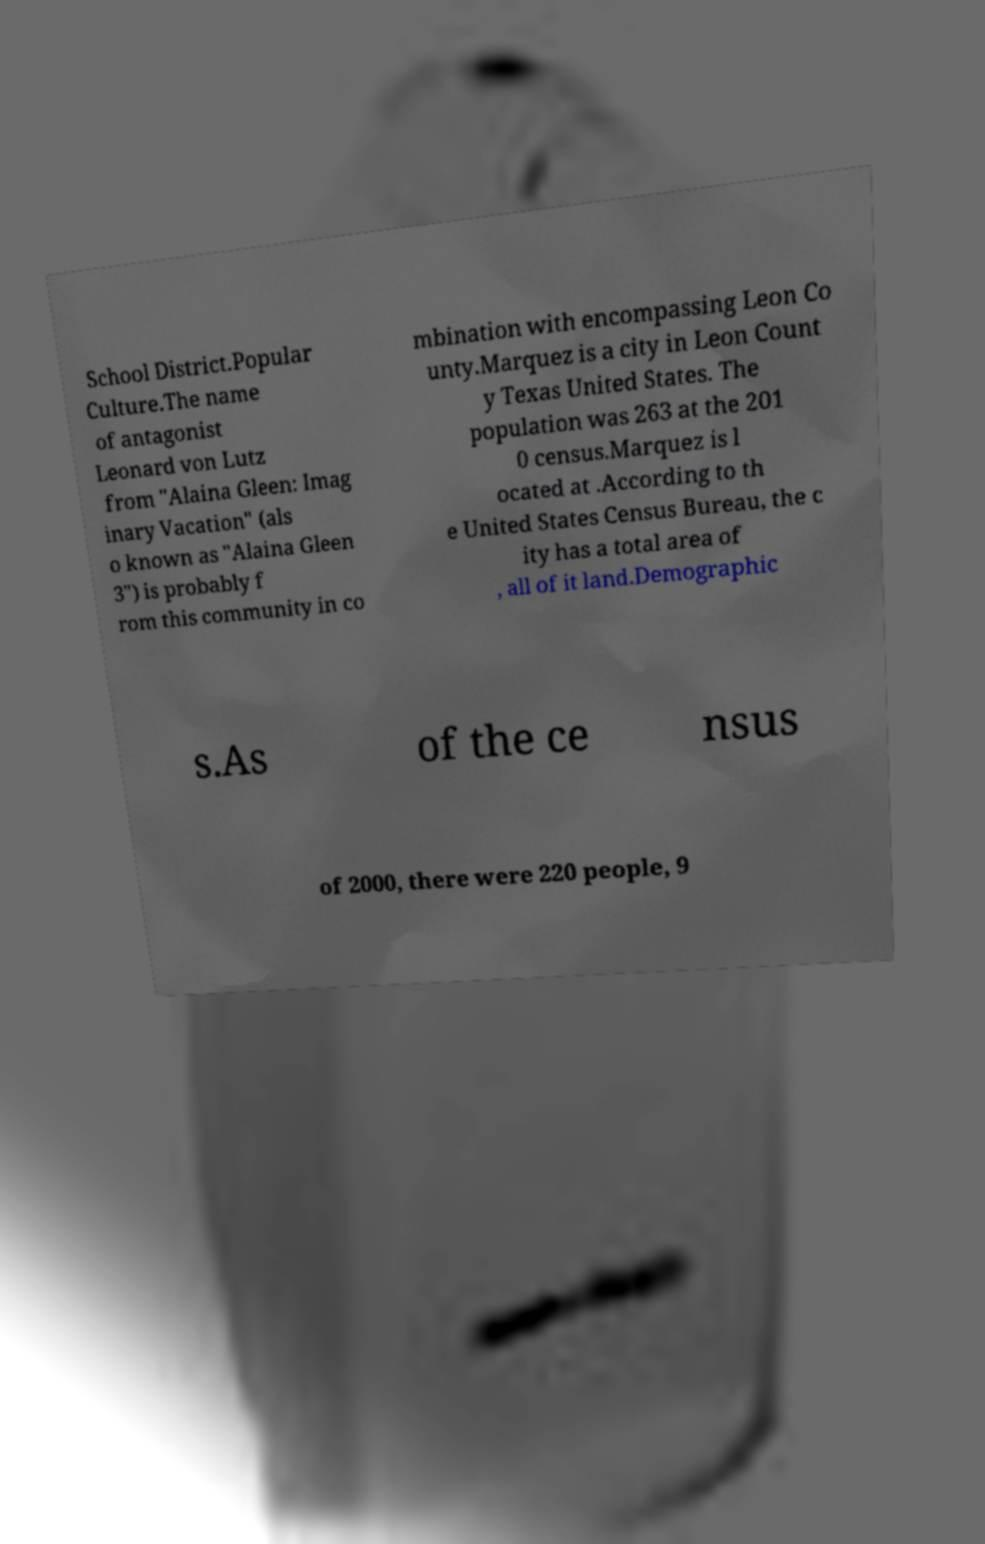For documentation purposes, I need the text within this image transcribed. Could you provide that? School District.Popular Culture.The name of antagonist Leonard von Lutz from "Alaina Gleen: Imag inary Vacation" (als o known as "Alaina Gleen 3") is probably f rom this community in co mbination with encompassing Leon Co unty.Marquez is a city in Leon Count y Texas United States. The population was 263 at the 201 0 census.Marquez is l ocated at .According to th e United States Census Bureau, the c ity has a total area of , all of it land.Demographic s.As of the ce nsus of 2000, there were 220 people, 9 